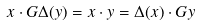<formula> <loc_0><loc_0><loc_500><loc_500>x \cdot G \Delta ( y ) = x \cdot y = \Delta ( x ) \cdot G y</formula> 